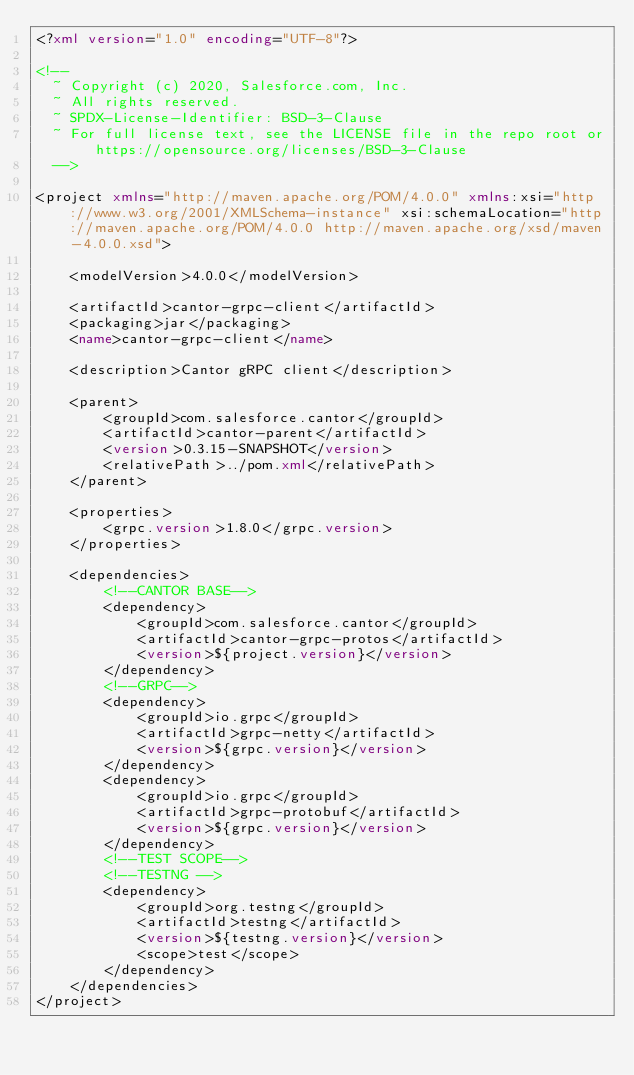Convert code to text. <code><loc_0><loc_0><loc_500><loc_500><_XML_><?xml version="1.0" encoding="UTF-8"?>

<!--
  ~ Copyright (c) 2020, Salesforce.com, Inc.
  ~ All rights reserved.
  ~ SPDX-License-Identifier: BSD-3-Clause
  ~ For full license text, see the LICENSE file in the repo root or https://opensource.org/licenses/BSD-3-Clause
  -->

<project xmlns="http://maven.apache.org/POM/4.0.0" xmlns:xsi="http://www.w3.org/2001/XMLSchema-instance" xsi:schemaLocation="http://maven.apache.org/POM/4.0.0 http://maven.apache.org/xsd/maven-4.0.0.xsd">

    <modelVersion>4.0.0</modelVersion>

    <artifactId>cantor-grpc-client</artifactId>
    <packaging>jar</packaging>
    <name>cantor-grpc-client</name>

    <description>Cantor gRPC client</description>

    <parent>
        <groupId>com.salesforce.cantor</groupId>
        <artifactId>cantor-parent</artifactId>
        <version>0.3.15-SNAPSHOT</version>
        <relativePath>../pom.xml</relativePath>
    </parent>

    <properties>
        <grpc.version>1.8.0</grpc.version>
    </properties>

    <dependencies>
        <!--CANTOR BASE-->
        <dependency>
            <groupId>com.salesforce.cantor</groupId>
            <artifactId>cantor-grpc-protos</artifactId>
            <version>${project.version}</version>
        </dependency>
        <!--GRPC-->
        <dependency>
            <groupId>io.grpc</groupId>
            <artifactId>grpc-netty</artifactId>
            <version>${grpc.version}</version>
        </dependency>
        <dependency>
            <groupId>io.grpc</groupId>
            <artifactId>grpc-protobuf</artifactId>
            <version>${grpc.version}</version>
        </dependency>
        <!--TEST SCOPE-->
        <!--TESTNG -->
        <dependency>
            <groupId>org.testng</groupId>
            <artifactId>testng</artifactId>
            <version>${testng.version}</version>
            <scope>test</scope>
        </dependency>
    </dependencies>
</project>

</code> 